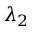Convert formula to latex. <formula><loc_0><loc_0><loc_500><loc_500>\lambda _ { 2 }</formula> 